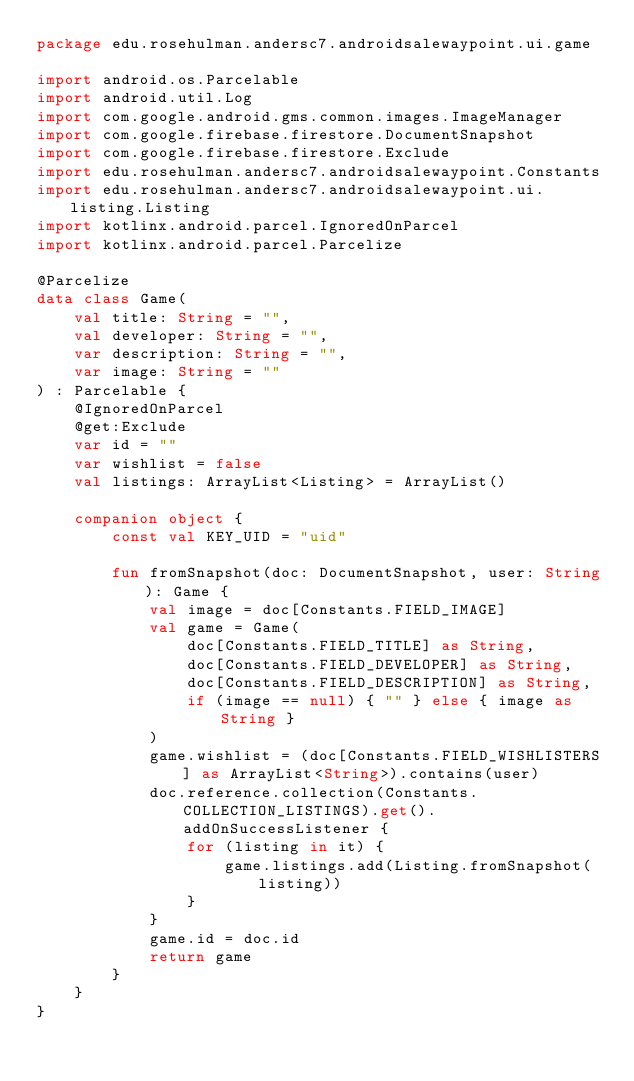Convert code to text. <code><loc_0><loc_0><loc_500><loc_500><_Kotlin_>package edu.rosehulman.andersc7.androidsalewaypoint.ui.game

import android.os.Parcelable
import android.util.Log
import com.google.android.gms.common.images.ImageManager
import com.google.firebase.firestore.DocumentSnapshot
import com.google.firebase.firestore.Exclude
import edu.rosehulman.andersc7.androidsalewaypoint.Constants
import edu.rosehulman.andersc7.androidsalewaypoint.ui.listing.Listing
import kotlinx.android.parcel.IgnoredOnParcel
import kotlinx.android.parcel.Parcelize

@Parcelize
data class Game(
	val title: String = "",
	val developer: String = "",
	var description: String = "",
	var image: String = ""
) : Parcelable {
	@IgnoredOnParcel
	@get:Exclude
	var id = ""
	var wishlist = false
	val listings: ArrayList<Listing> = ArrayList()

	companion object {
		const val KEY_UID = "uid"

		fun fromSnapshot(doc: DocumentSnapshot, user: String): Game {
			val image = doc[Constants.FIELD_IMAGE]
			val game = Game(
				doc[Constants.FIELD_TITLE] as String,
				doc[Constants.FIELD_DEVELOPER] as String,
				doc[Constants.FIELD_DESCRIPTION] as String,
				if (image == null) { "" } else { image as String }
			)
			game.wishlist = (doc[Constants.FIELD_WISHLISTERS] as ArrayList<String>).contains(user)
			doc.reference.collection(Constants.COLLECTION_LISTINGS).get().addOnSuccessListener {
				for (listing in it) {
					game.listings.add(Listing.fromSnapshot(listing))
				}
			}
			game.id = doc.id
			return game
		}
	}
}
</code> 